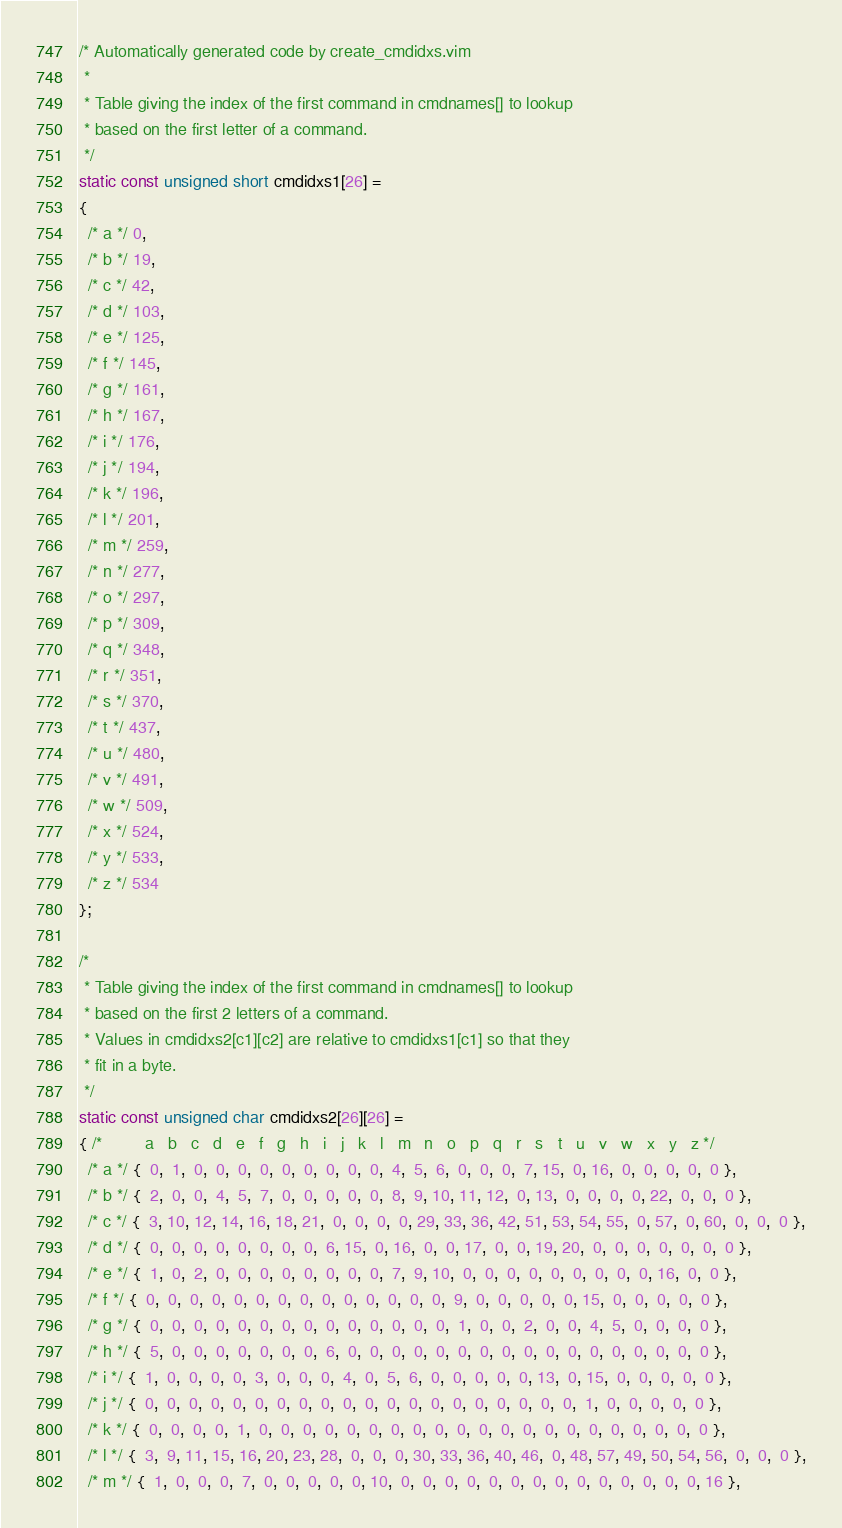<code> <loc_0><loc_0><loc_500><loc_500><_C_>/* Automatically generated code by create_cmdidxs.vim
 *
 * Table giving the index of the first command in cmdnames[] to lookup
 * based on the first letter of a command.
 */
static const unsigned short cmdidxs1[26] =
{
  /* a */ 0,
  /* b */ 19,
  /* c */ 42,
  /* d */ 103,
  /* e */ 125,
  /* f */ 145,
  /* g */ 161,
  /* h */ 167,
  /* i */ 176,
  /* j */ 194,
  /* k */ 196,
  /* l */ 201,
  /* m */ 259,
  /* n */ 277,
  /* o */ 297,
  /* p */ 309,
  /* q */ 348,
  /* r */ 351,
  /* s */ 370,
  /* t */ 437,
  /* u */ 480,
  /* v */ 491,
  /* w */ 509,
  /* x */ 524,
  /* y */ 533,
  /* z */ 534
};

/*
 * Table giving the index of the first command in cmdnames[] to lookup
 * based on the first 2 letters of a command.
 * Values in cmdidxs2[c1][c2] are relative to cmdidxs1[c1] so that they
 * fit in a byte.
 */
static const unsigned char cmdidxs2[26][26] =
{ /*         a   b   c   d   e   f   g   h   i   j   k   l   m   n   o   p   q   r   s   t   u   v   w   x   y   z */
  /* a */ {  0,  1,  0,  0,  0,  0,  0,  0,  0,  0,  0,  4,  5,  6,  0,  0,  0,  7, 15,  0, 16,  0,  0,  0,  0,  0 },
  /* b */ {  2,  0,  0,  4,  5,  7,  0,  0,  0,  0,  0,  8,  9, 10, 11, 12,  0, 13,  0,  0,  0,  0, 22,  0,  0,  0 },
  /* c */ {  3, 10, 12, 14, 16, 18, 21,  0,  0,  0,  0, 29, 33, 36, 42, 51, 53, 54, 55,  0, 57,  0, 60,  0,  0,  0 },
  /* d */ {  0,  0,  0,  0,  0,  0,  0,  0,  6, 15,  0, 16,  0,  0, 17,  0,  0, 19, 20,  0,  0,  0,  0,  0,  0,  0 },
  /* e */ {  1,  0,  2,  0,  0,  0,  0,  0,  0,  0,  0,  7,  9, 10,  0,  0,  0,  0,  0,  0,  0,  0,  0, 16,  0,  0 },
  /* f */ {  0,  0,  0,  0,  0,  0,  0,  0,  0,  0,  0,  0,  0,  0,  9,  0,  0,  0,  0,  0, 15,  0,  0,  0,  0,  0 },
  /* g */ {  0,  0,  0,  0,  0,  0,  0,  0,  0,  0,  0,  0,  0,  0,  1,  0,  0,  2,  0,  0,  4,  5,  0,  0,  0,  0 },
  /* h */ {  5,  0,  0,  0,  0,  0,  0,  0,  6,  0,  0,  0,  0,  0,  0,  0,  0,  0,  0,  0,  0,  0,  0,  0,  0,  0 },
  /* i */ {  1,  0,  0,  0,  0,  3,  0,  0,  0,  4,  0,  5,  6,  0,  0,  0,  0,  0, 13,  0, 15,  0,  0,  0,  0,  0 },
  /* j */ {  0,  0,  0,  0,  0,  0,  0,  0,  0,  0,  0,  0,  0,  0,  0,  0,  0,  0,  0,  0,  1,  0,  0,  0,  0,  0 },
  /* k */ {  0,  0,  0,  0,  1,  0,  0,  0,  0,  0,  0,  0,  0,  0,  0,  0,  0,  0,  0,  0,  0,  0,  0,  0,  0,  0 },
  /* l */ {  3,  9, 11, 15, 16, 20, 23, 28,  0,  0,  0, 30, 33, 36, 40, 46,  0, 48, 57, 49, 50, 54, 56,  0,  0,  0 },
  /* m */ {  1,  0,  0,  0,  7,  0,  0,  0,  0,  0, 10,  0,  0,  0,  0,  0,  0,  0,  0,  0,  0,  0,  0,  0,  0, 16 },</code> 